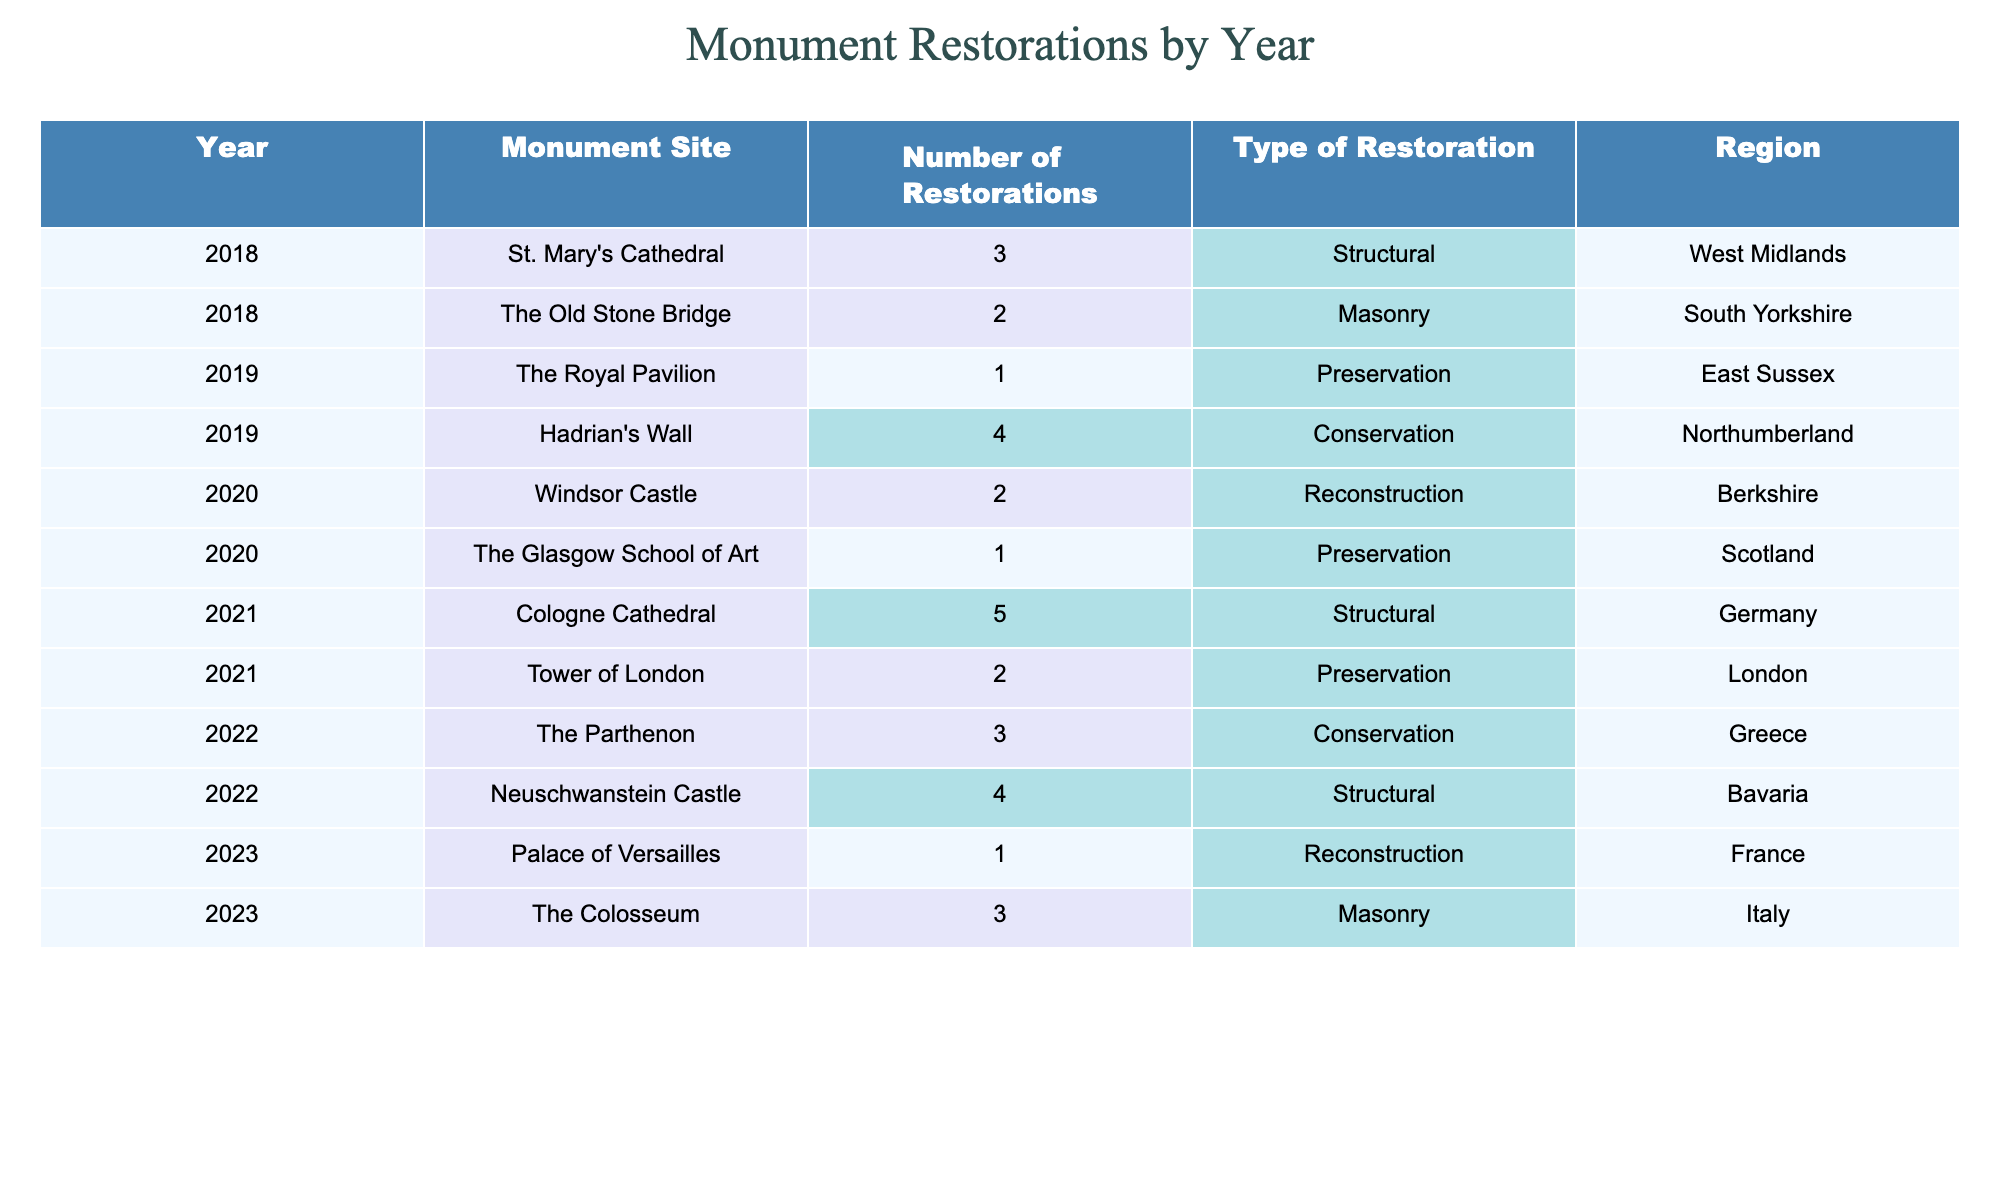What is the total number of restorations completed in 2022? In 2022, there were two monument sites: The Parthenon (3 restorations) and Neuschwanstein Castle (4 restorations). Adding these together gives 3 + 4 = 7 restorations.
Answer: 7 Which monument site had the highest number of restorations in 2021? The table shows that Cologne Cathedral had 5 restorations in 2021, which is the highest among all monument sites for that year.
Answer: Cologne Cathedral How many more restorations were completed in 2020 than in 2019? In 2020, there were 2 restorations at Windsor Castle and 1 at The Glasgow School of Art, totaling 3 restorations. In 2019, there were 1 at The Royal Pavilion and 4 at Hadrian's Wall, totaling 5 restorations. Therefore, the difference is 3 - 5 = -2 restorations (meaning 2019 had 2 more).
Answer: 2 Is there a year when no restorations were recorded? Reviewing the table, there are restorations recorded for each year listed (2018, 2019, 2020, 2021, 2022, and 2023). Therefore, the statement is false.
Answer: No What is the average number of restorations per year from 2018 to 2023? The total restorations from 2018 to 2023 are: 3 + 2 + 1 + 4 + 2 + 1 + 5 + 2 + 3 + 4 + 1 + 3 = 28 restorations across 6 years. The average is 28 / 6 ≈ 4.67 restorations per year.
Answer: Approximately 4.67 Which region had the most restorations completed in total? By adding the restorations per region: West Midlands (3), South Yorkshire (2), East Sussex (1), Northumberland (4), Berkshire (2), Scotland (1), Germany (5), London (2), Greece (3), Bavaria (4), France (1), Italy (3). The total for Germany is the highest at 5.
Answer: Germany How many restorations did The Colosseum have compared to Windsor Castle? The Colosseum had 3 restorations and Windsor Castle had 2 restorations. The difference is 3 - 2 = 1 restoration more for The Colosseum.
Answer: 1 What type of restoration was most common in 2021? In 2021, the types of restorations were: Structural (5 for Cologne Cathedral), Preservation (2 for Tower of London). The most common type was Structural with 5 restorations.
Answer: Structural In which year was there a monument restoration that involved reconstruction? The table includes reconstructions in 2020 (Windsor Castle) and 2023 (Palace of Versailles). Thus, reconstructive restorations occurred in both years.
Answer: 2020 and 2023 What is the total number of restorations completed from all years for masonry type? The data shows masonry restorations for The Old Stone Bridge (2), and The Colosseum (3). Adding these gives a total of 2 + 3 = 5 masonry restorations.
Answer: 5 